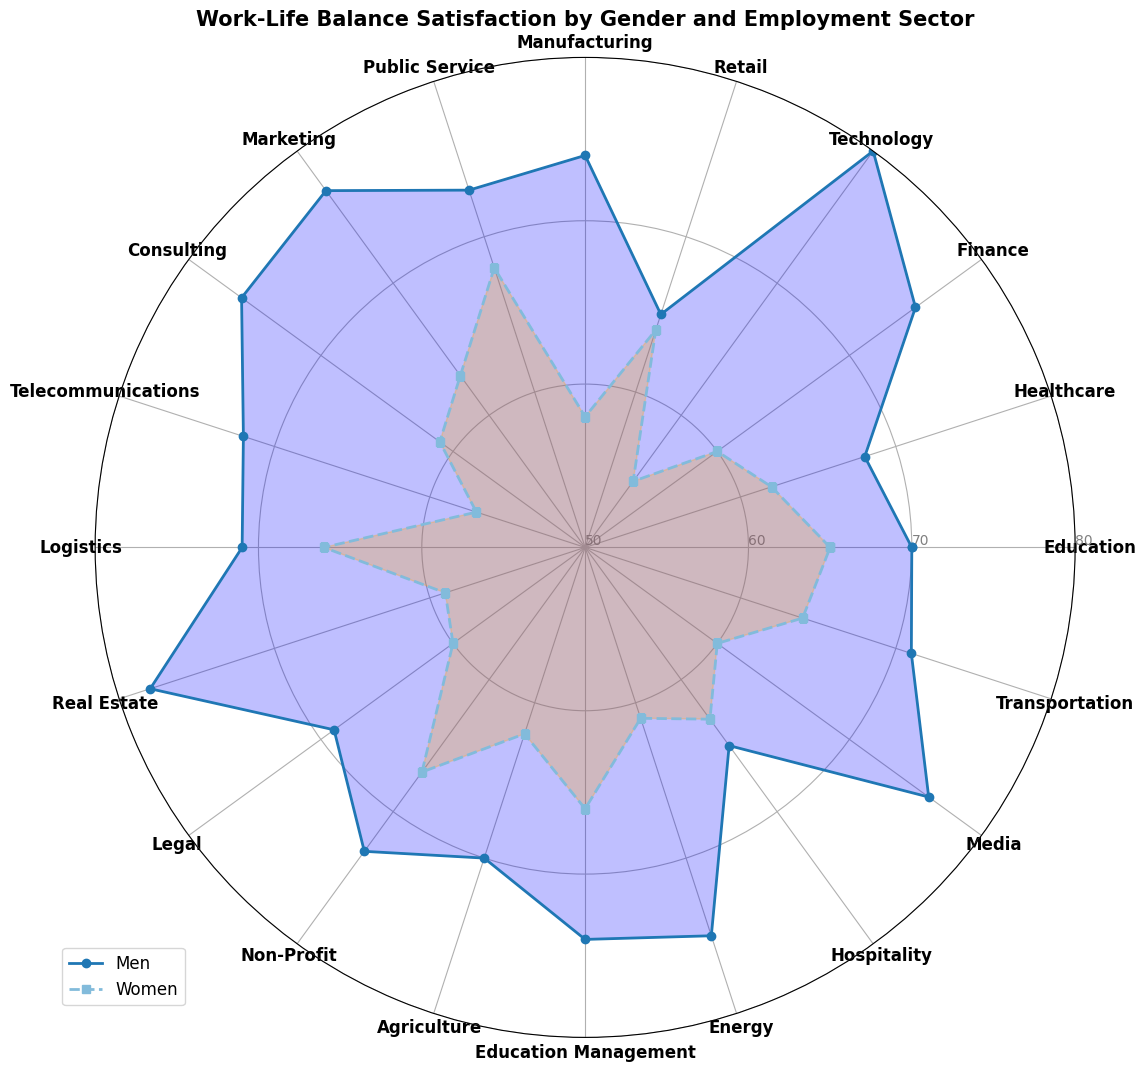What is the difference in Work-Life Balance Satisfaction between men and women in Technology? Look at the scores for Technology in the radar chart. Subtract the Women's score (55) from the Men's score (80).
Answer: 25 Which sector shows the smallest difference in Work-Life Balance Satisfaction between men and women? Compare the differences between men's and women's scores in each sector in the radar chart. The smallest difference is in the Retail sector, where the difference is only 1 point (Men: 65, Women: 64).
Answer: Retail In which sector do women report higher Work-Life Balance Satisfaction than men? Examine the radar chart for sectors where Women's scores are higher than Men's scores. Women report higher satisfaction in the Public Service sector (Women: 68, Men: 73).
Answer: Public Service What is the average Work-Life Balance Satisfaction score for men across all sectors? Sum the satisfaction scores for men across all sectors and divide by the number of sectors (20).
Answer: 72.1 How many sectors have a Work-Life Balance Satisfaction score of at least 70 for both men and women? Count the sectors in the radar chart where both men's and women's scores are 70 or higher. These sectors are Education, Manufacturing, Public Service, Education Management.
Answer: 4 Which sector has the highest Work-Life Balance Satisfaction score for men? Identify the sector with the highest peak among the values for men in the radar chart. The highest score for men is in Technology (80).
Answer: Technology What is the median Work-Life Balance Satisfaction score for women across all sectors? Arrange the scores for women in ascending order and find the middle value. The scores are `55, 57, 58, 59, 60, 60, 60, 61, 62, 62, 63, 63, 64, 64, 65, 66, 66, 67, 68, 68`. The middle values are 63 and 64, so the median is (63 + 64) / 2 = 63.5.
Answer: 63.5 Which sector shows the most significant disparity in Work-Life Balance Satisfaction between men and women? Identify the sector with the highest absolute difference between men's and women's scores from the radar chart. The most significant disparity is in Technology with a difference of 25 points (Men: 80, Women: 55).
Answer: Technology 